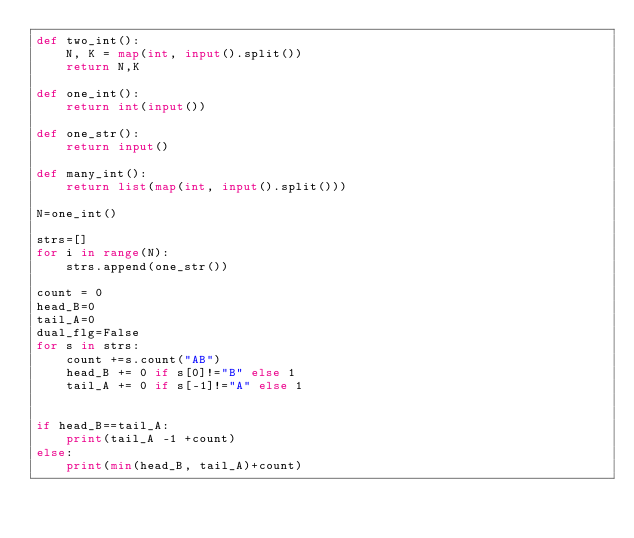<code> <loc_0><loc_0><loc_500><loc_500><_Python_>def two_int():
    N, K = map(int, input().split())
    return N,K

def one_int():
    return int(input())

def one_str():
    return input()

def many_int():
    return list(map(int, input().split()))

N=one_int()

strs=[]
for i in range(N):
    strs.append(one_str())

count = 0
head_B=0
tail_A=0
dual_flg=False
for s in strs:
    count +=s.count("AB")
    head_B += 0 if s[0]!="B" else 1
    tail_A += 0 if s[-1]!="A" else 1 


if head_B==tail_A:
    print(tail_A -1 +count)
else:
    print(min(head_B, tail_A)+count)

</code> 